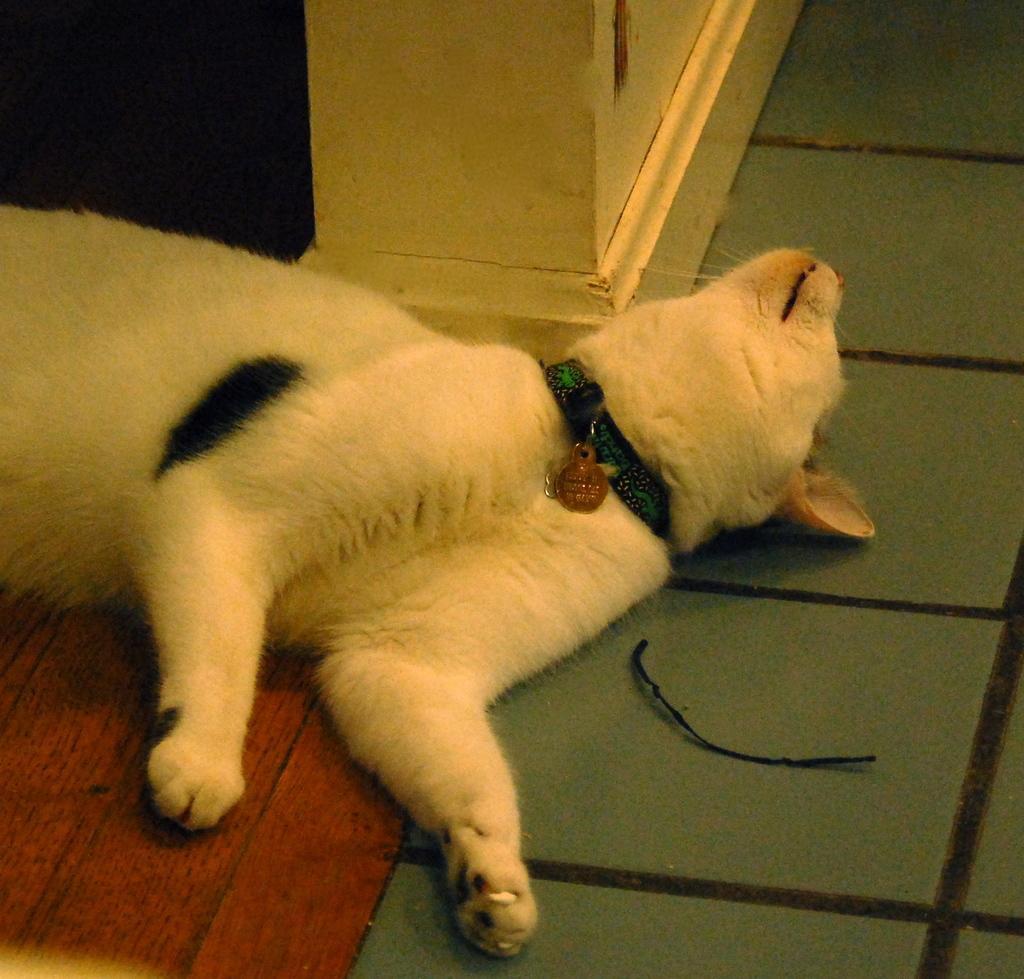Can you describe this image briefly? In this picture there is a dog lying on the floor and wall. In the background of the image it is dark. 